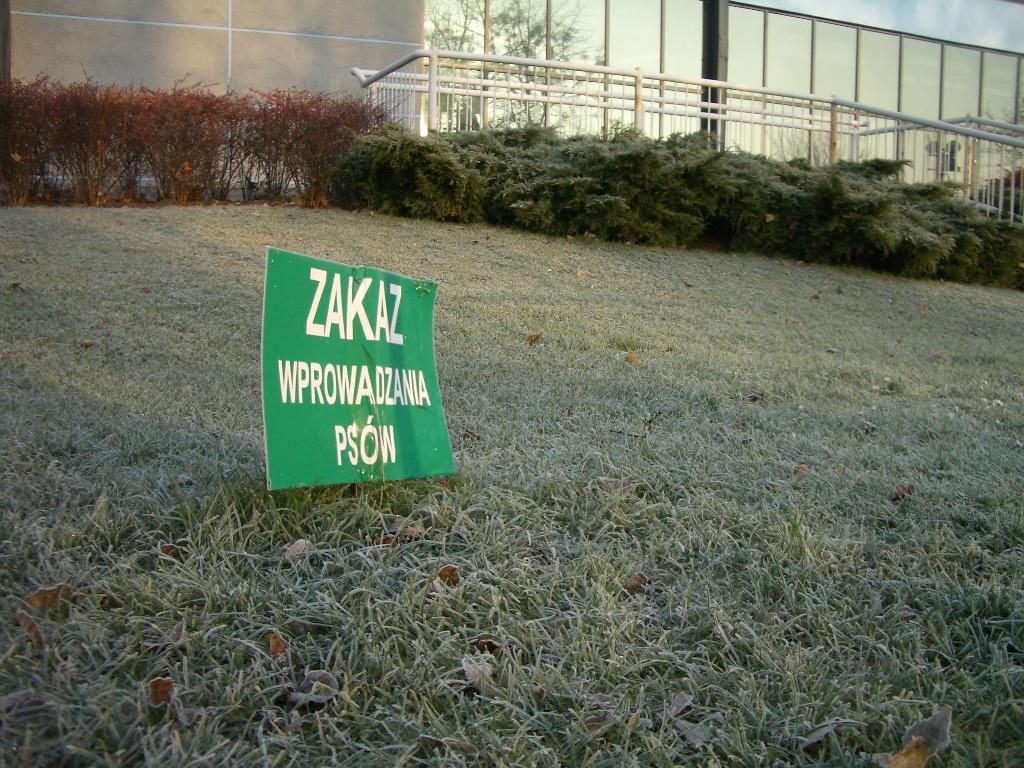What is present on the ground in the image? There is a banner on the ground in the image. What is the surface of the ground covered with? The ground is covered with grass. What can be seen in the background of the image? There are plants and bushes in the background of the image. What type of stew is being served on the banner in the image? There is no stew present in the image; the banner is on the ground and does not depict any food items. 